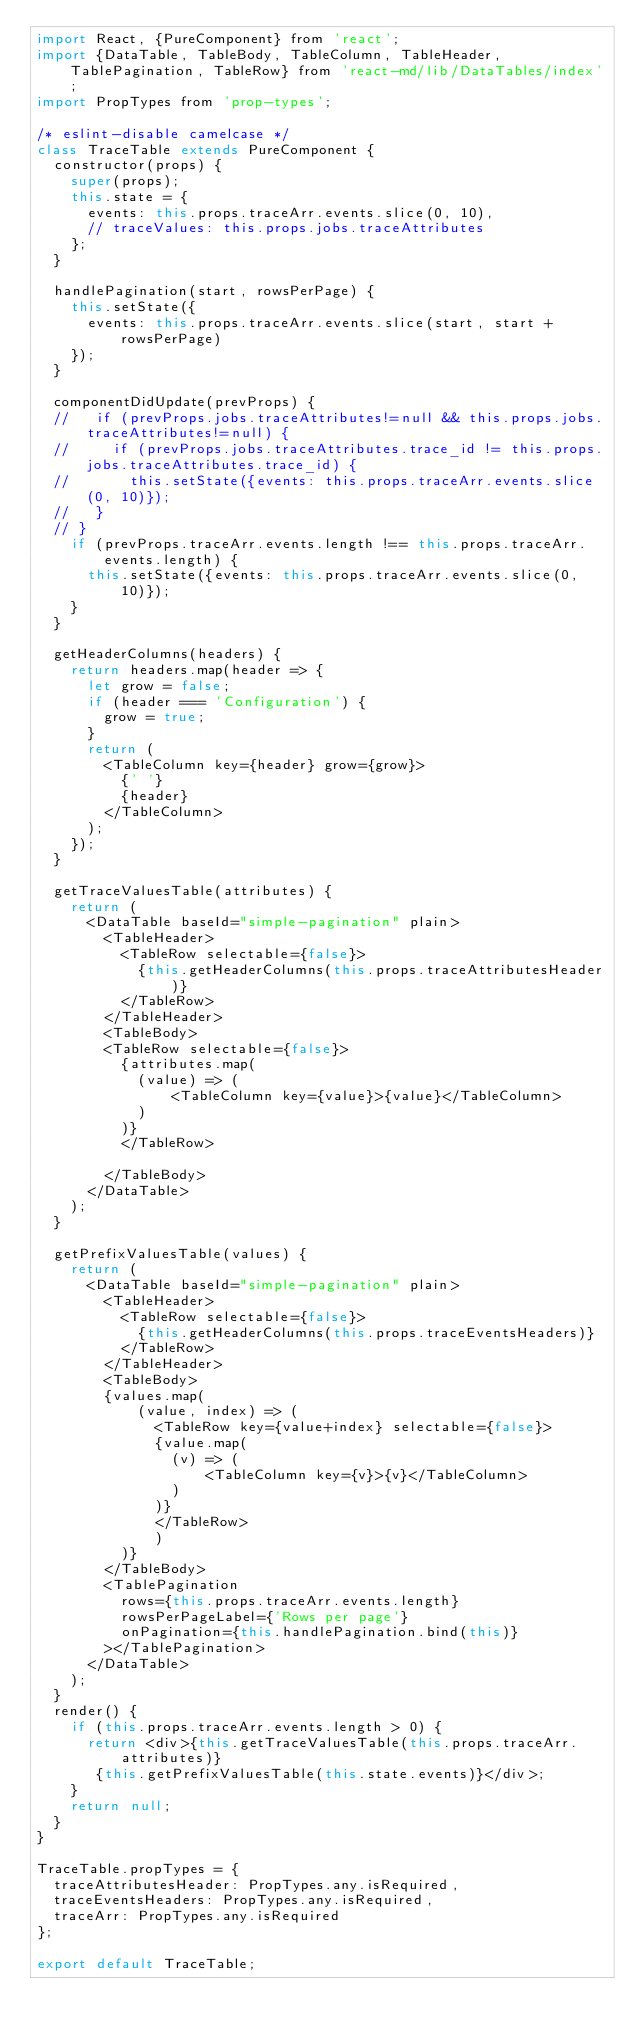Convert code to text. <code><loc_0><loc_0><loc_500><loc_500><_JavaScript_>import React, {PureComponent} from 'react';
import {DataTable, TableBody, TableColumn, TableHeader, TablePagination, TableRow} from 'react-md/lib/DataTables/index';
import PropTypes from 'prop-types';

/* eslint-disable camelcase */
class TraceTable extends PureComponent {
  constructor(props) {
    super(props);
    this.state = {
      events: this.props.traceArr.events.slice(0, 10),
      // traceValues: this.props.jobs.traceAttributes
    };
  }

  handlePagination(start, rowsPerPage) {
    this.setState({
      events: this.props.traceArr.events.slice(start, start + rowsPerPage)
    });
  }

  componentDidUpdate(prevProps) {
  //   if (prevProps.jobs.traceAttributes!=null && this.props.jobs.traceAttributes!=null) {
  //     if (prevProps.jobs.traceAttributes.trace_id != this.props.jobs.traceAttributes.trace_id) {
  //       this.setState({events: this.props.traceArr.events.slice(0, 10)});
  //   }
  // }
    if (prevProps.traceArr.events.length !== this.props.traceArr.events.length) {
      this.setState({events: this.props.traceArr.events.slice(0, 10)});
    }
  }

  getHeaderColumns(headers) {
    return headers.map(header => {
      let grow = false;
      if (header === 'Configuration') {
        grow = true;
      }
      return (
        <TableColumn key={header} grow={grow}>
          {' '}
          {header}
        </TableColumn>
      );
    });
  }

  getTraceValuesTable(attributes) {
    return (
      <DataTable baseId="simple-pagination" plain>
        <TableHeader>
          <TableRow selectable={false}>
            {this.getHeaderColumns(this.props.traceAttributesHeader)}
          </TableRow>
        </TableHeader>
        <TableBody>
        <TableRow selectable={false}>
          {attributes.map(
            (value) => (
                <TableColumn key={value}>{value}</TableColumn>
            )
          )}
          </TableRow>

        </TableBody>
      </DataTable>
    );
  }

  getPrefixValuesTable(values) {
    return (
      <DataTable baseId="simple-pagination" plain>
        <TableHeader>
          <TableRow selectable={false}>
            {this.getHeaderColumns(this.props.traceEventsHeaders)}
          </TableRow>
        </TableHeader>
        <TableBody>
        {values.map(
            (value, index) => (
              <TableRow key={value+index} selectable={false}>
              {value.map(
                (v) => (
                    <TableColumn key={v}>{v}</TableColumn>
                )
              )}
              </TableRow>
              )
          )}
        </TableBody>
        <TablePagination
          rows={this.props.traceArr.events.length}
          rowsPerPageLabel={'Rows per page'}
          onPagination={this.handlePagination.bind(this)}
        ></TablePagination>
      </DataTable>
    );
  }
  render() {
    if (this.props.traceArr.events.length > 0) {
      return <div>{this.getTraceValuesTable(this.props.traceArr.attributes)}
       {this.getPrefixValuesTable(this.state.events)}</div>;
    }
    return null;
  }
}

TraceTable.propTypes = {
  traceAttributesHeader: PropTypes.any.isRequired,
  traceEventsHeaders: PropTypes.any.isRequired,
  traceArr: PropTypes.any.isRequired
};

export default TraceTable;
</code> 